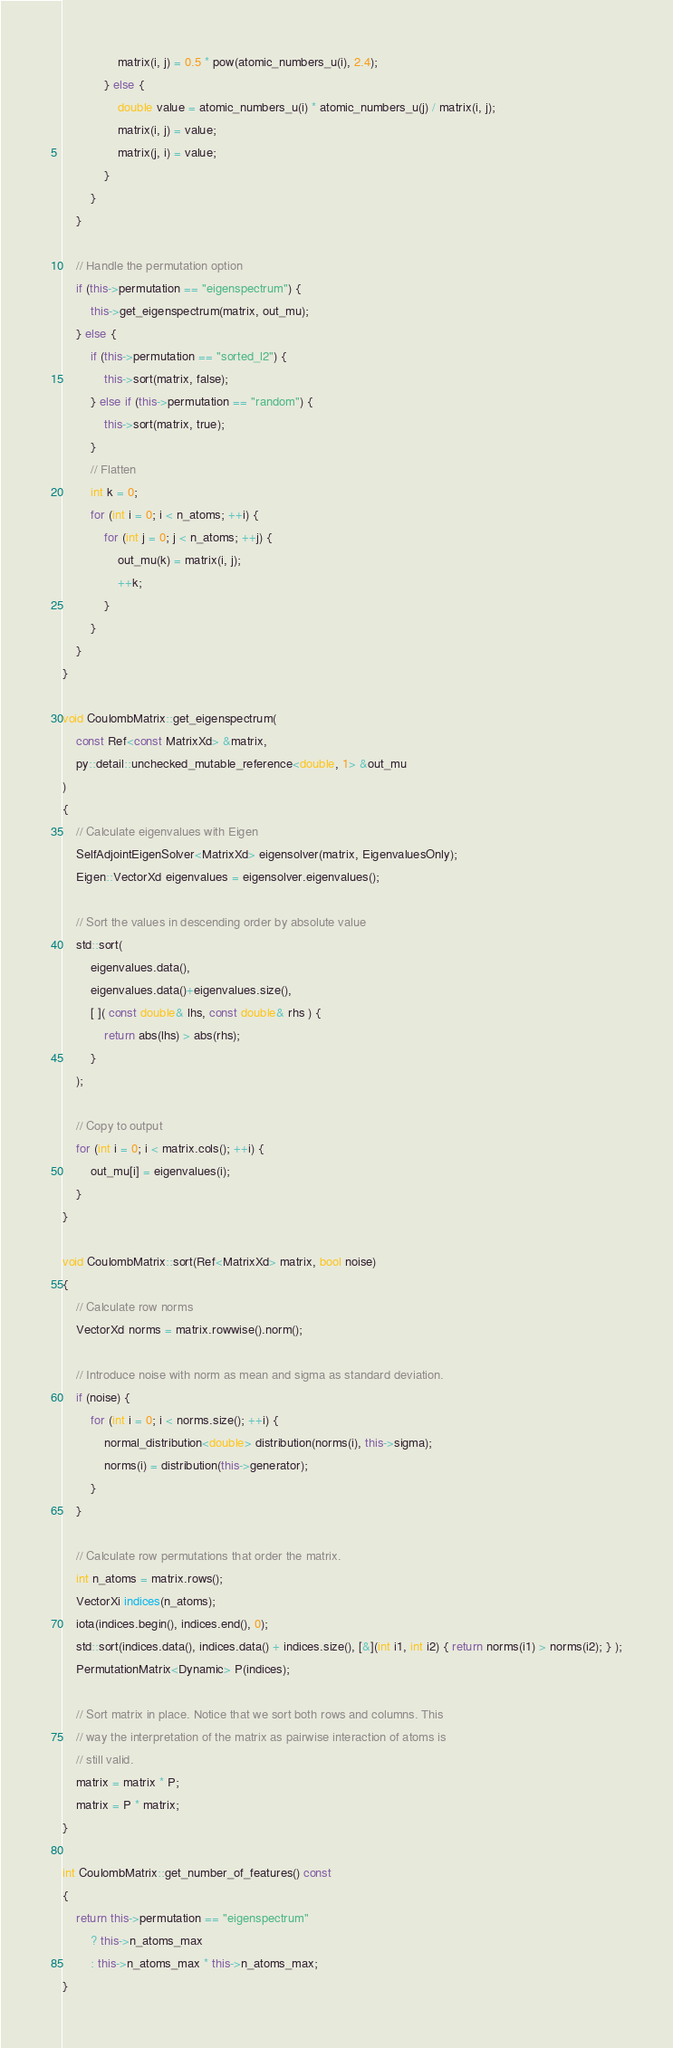Convert code to text. <code><loc_0><loc_0><loc_500><loc_500><_C++_>                matrix(i, j) = 0.5 * pow(atomic_numbers_u(i), 2.4);
            } else {
                double value = atomic_numbers_u(i) * atomic_numbers_u(j) / matrix(i, j);
                matrix(i, j) = value;
                matrix(j, i) = value;
            }
        }
    }

    // Handle the permutation option
    if (this->permutation == "eigenspectrum") {
        this->get_eigenspectrum(matrix, out_mu);
    } else {
        if (this->permutation == "sorted_l2") {
            this->sort(matrix, false);
        } else if (this->permutation == "random") {
            this->sort(matrix, true);
        }
        // Flatten
        int k = 0;
        for (int i = 0; i < n_atoms; ++i) {
            for (int j = 0; j < n_atoms; ++j) {
                out_mu(k) = matrix(i, j);
                ++k;
            }
        }
    }
}

void CoulombMatrix::get_eigenspectrum(
    const Ref<const MatrixXd> &matrix,
    py::detail::unchecked_mutable_reference<double, 1> &out_mu
)
{
    // Calculate eigenvalues with Eigen
    SelfAdjointEigenSolver<MatrixXd> eigensolver(matrix, EigenvaluesOnly);
    Eigen::VectorXd eigenvalues = eigensolver.eigenvalues();

    // Sort the values in descending order by absolute value
    std::sort(
        eigenvalues.data(),
        eigenvalues.data()+eigenvalues.size(),
        [ ]( const double& lhs, const double& rhs ) {
            return abs(lhs) > abs(rhs);
        }
    );

    // Copy to output
    for (int i = 0; i < matrix.cols(); ++i) {
        out_mu[i] = eigenvalues(i);
    }
}

void CoulombMatrix::sort(Ref<MatrixXd> matrix, bool noise)
{
    // Calculate row norms
    VectorXd norms = matrix.rowwise().norm();

    // Introduce noise with norm as mean and sigma as standard deviation.
    if (noise) {
        for (int i = 0; i < norms.size(); ++i) {
            normal_distribution<double> distribution(norms(i), this->sigma);
            norms(i) = distribution(this->generator);
        }
    }

    // Calculate row permutations that order the matrix.
    int n_atoms = matrix.rows();
    VectorXi indices(n_atoms);
    iota(indices.begin(), indices.end(), 0);
    std::sort(indices.data(), indices.data() + indices.size(), [&](int i1, int i2) { return norms(i1) > norms(i2); } );
    PermutationMatrix<Dynamic> P(indices);

    // Sort matrix in place. Notice that we sort both rows and columns. This
    // way the interpretation of the matrix as pairwise interaction of atoms is
    // still valid.
    matrix = matrix * P;
    matrix = P * matrix;
}

int CoulombMatrix::get_number_of_features() const
{
    return this->permutation == "eigenspectrum"
        ? this->n_atoms_max
        : this->n_atoms_max * this->n_atoms_max;
}
</code> 